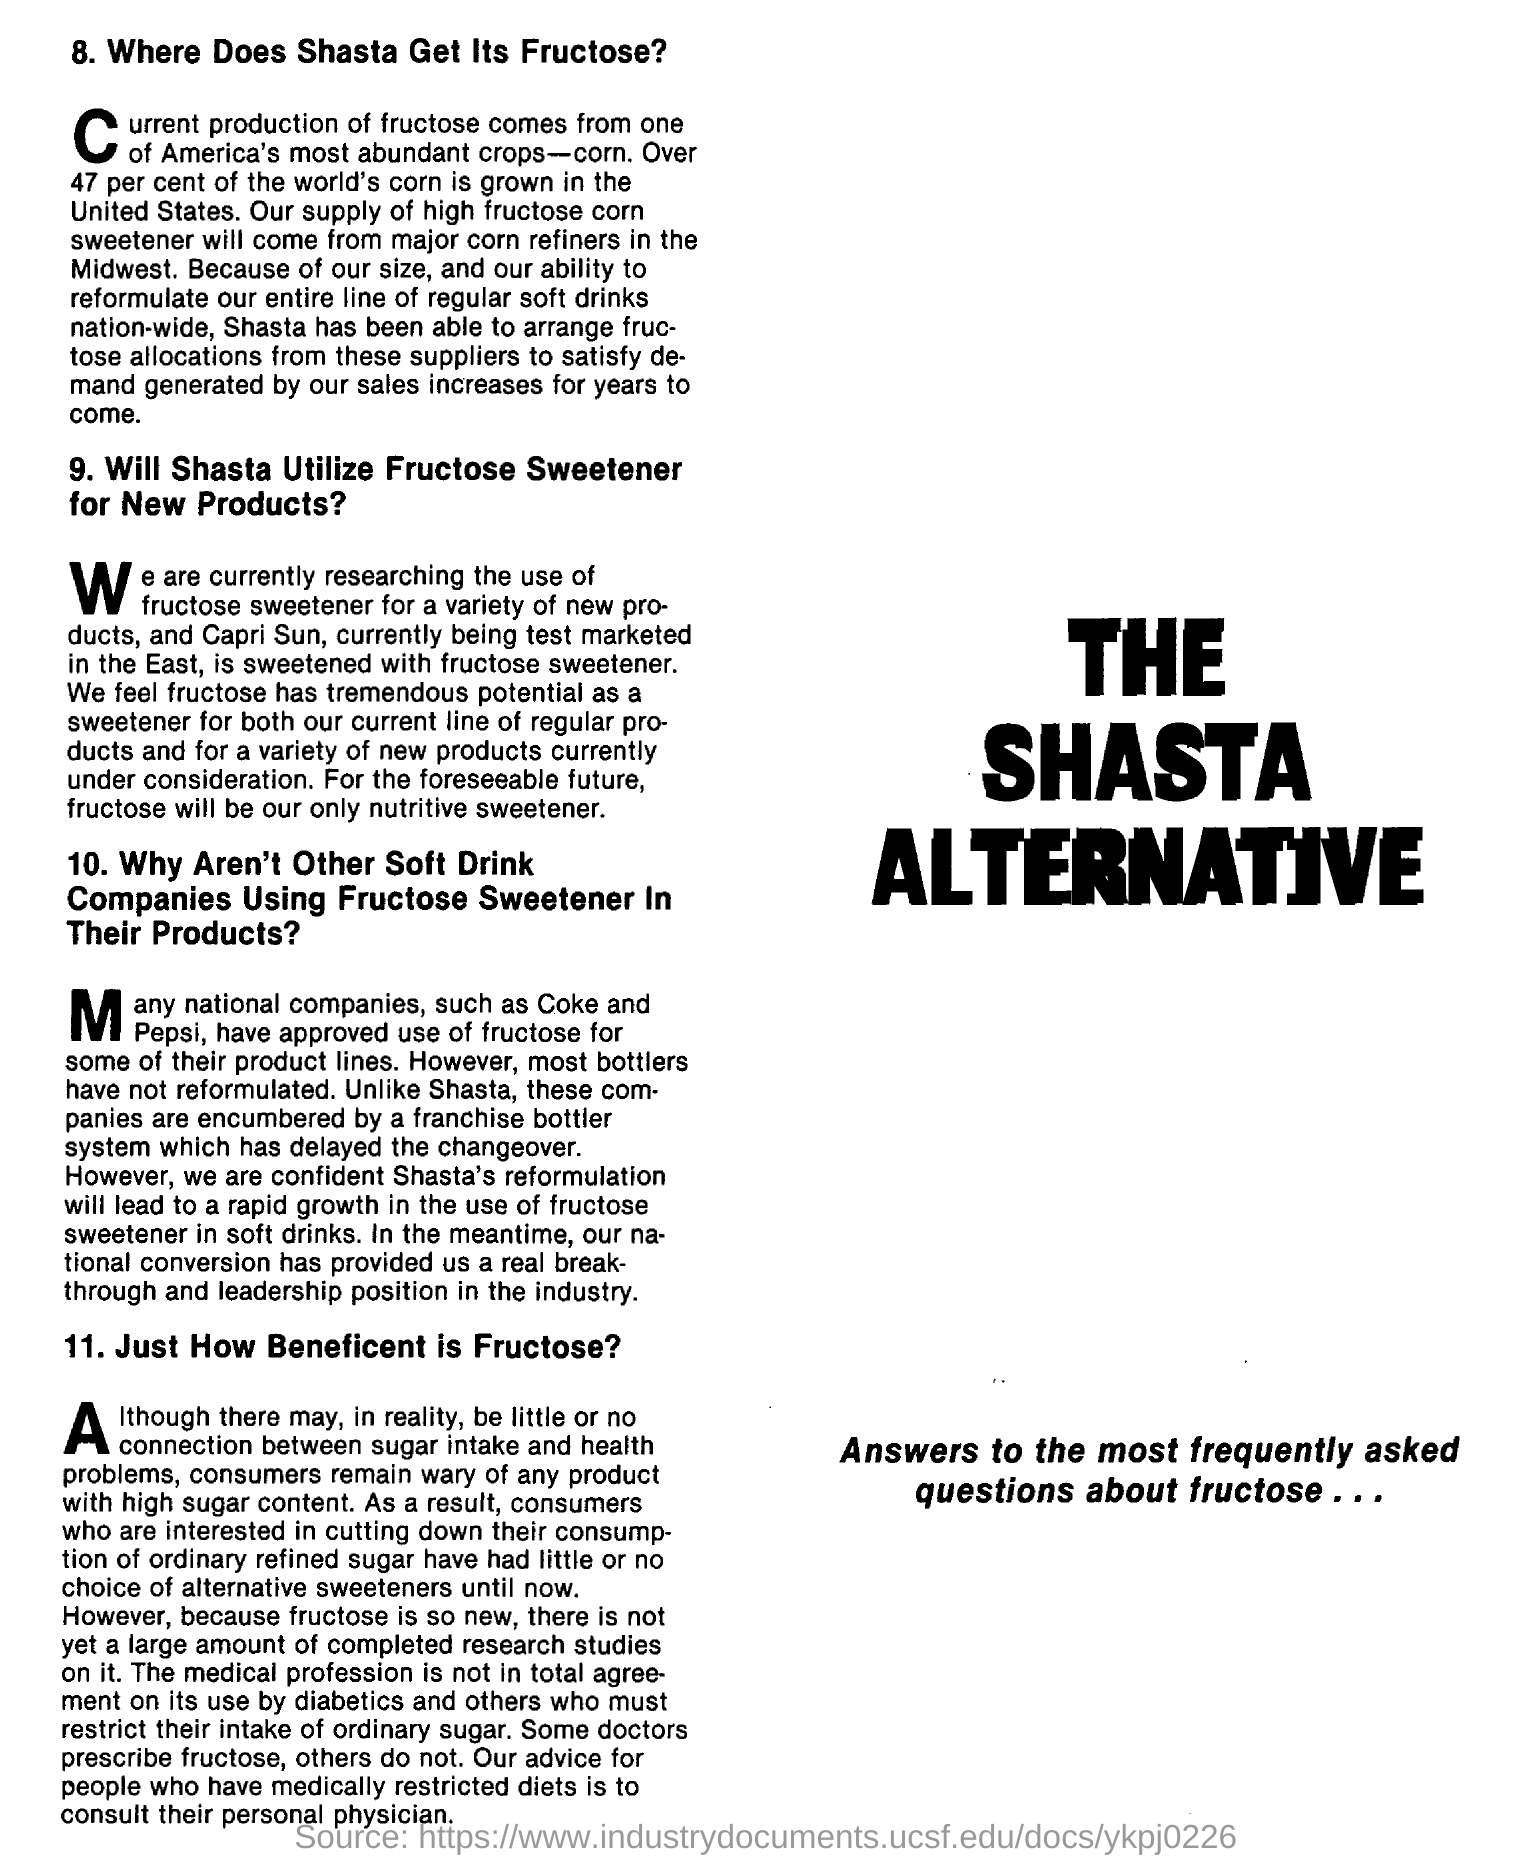Draw attention to some important aspects in this diagram. The majority of high fructose corn syrup in the United States is produced by major corn refiners in the Midwest. The franchise bottler system is the reason why companies like Coca-Cola and Pepsi do not widely use fructose. For the foreseeable future, fructose will be our only nutritive sweetener. 